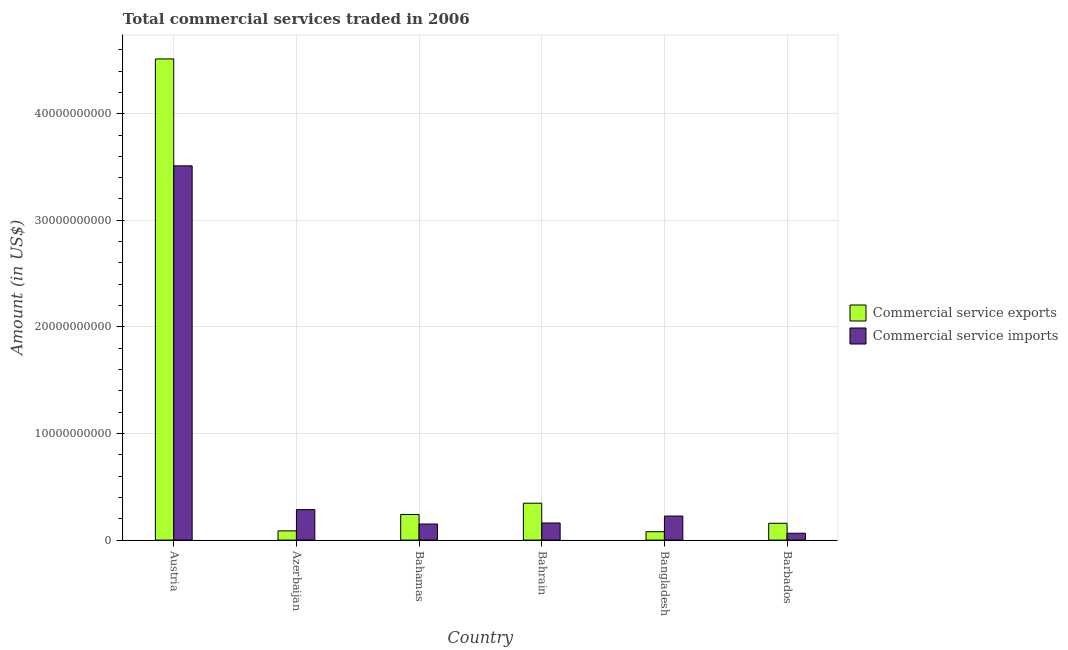What is the label of the 1st group of bars from the left?
Offer a terse response. Austria. In how many cases, is the number of bars for a given country not equal to the number of legend labels?
Offer a very short reply. 0. What is the amount of commercial service exports in Bahrain?
Keep it short and to the point. 3.46e+09. Across all countries, what is the maximum amount of commercial service imports?
Your answer should be very brief. 3.51e+1. Across all countries, what is the minimum amount of commercial service imports?
Offer a terse response. 6.43e+08. In which country was the amount of commercial service imports maximum?
Your response must be concise. Austria. In which country was the amount of commercial service exports minimum?
Ensure brevity in your answer.  Bangladesh. What is the total amount of commercial service imports in the graph?
Your answer should be compact. 4.40e+1. What is the difference between the amount of commercial service exports in Bahrain and that in Bangladesh?
Offer a very short reply. 2.68e+09. What is the difference between the amount of commercial service exports in Bangladesh and the amount of commercial service imports in Bahrain?
Provide a short and direct response. -8.19e+08. What is the average amount of commercial service imports per country?
Give a very brief answer. 7.33e+09. What is the difference between the amount of commercial service imports and amount of commercial service exports in Barbados?
Provide a short and direct response. -9.36e+08. In how many countries, is the amount of commercial service exports greater than 44000000000 US$?
Offer a terse response. 1. What is the ratio of the amount of commercial service imports in Austria to that in Bangladesh?
Offer a very short reply. 15.57. What is the difference between the highest and the second highest amount of commercial service exports?
Make the answer very short. 4.17e+1. What is the difference between the highest and the lowest amount of commercial service exports?
Your response must be concise. 4.44e+1. What does the 1st bar from the left in Bahrain represents?
Your response must be concise. Commercial service exports. What does the 2nd bar from the right in Barbados represents?
Provide a succinct answer. Commercial service exports. Are all the bars in the graph horizontal?
Offer a very short reply. No. What is the difference between two consecutive major ticks on the Y-axis?
Give a very brief answer. 1.00e+1. Are the values on the major ticks of Y-axis written in scientific E-notation?
Your response must be concise. No. Does the graph contain any zero values?
Your answer should be compact. No. Does the graph contain grids?
Your answer should be very brief. Yes. Where does the legend appear in the graph?
Your response must be concise. Center right. How many legend labels are there?
Your response must be concise. 2. What is the title of the graph?
Keep it short and to the point. Total commercial services traded in 2006. What is the label or title of the Y-axis?
Your answer should be very brief. Amount (in US$). What is the Amount (in US$) of Commercial service exports in Austria?
Your answer should be compact. 4.51e+1. What is the Amount (in US$) of Commercial service imports in Austria?
Ensure brevity in your answer.  3.51e+1. What is the Amount (in US$) in Commercial service exports in Azerbaijan?
Provide a succinct answer. 8.67e+08. What is the Amount (in US$) in Commercial service imports in Azerbaijan?
Ensure brevity in your answer.  2.86e+09. What is the Amount (in US$) in Commercial service exports in Bahamas?
Your answer should be very brief. 2.40e+09. What is the Amount (in US$) in Commercial service imports in Bahamas?
Your answer should be very brief. 1.51e+09. What is the Amount (in US$) of Commercial service exports in Bahrain?
Give a very brief answer. 3.46e+09. What is the Amount (in US$) of Commercial service imports in Bahrain?
Give a very brief answer. 1.61e+09. What is the Amount (in US$) in Commercial service exports in Bangladesh?
Ensure brevity in your answer.  7.87e+08. What is the Amount (in US$) of Commercial service imports in Bangladesh?
Make the answer very short. 2.26e+09. What is the Amount (in US$) of Commercial service exports in Barbados?
Give a very brief answer. 1.58e+09. What is the Amount (in US$) in Commercial service imports in Barbados?
Keep it short and to the point. 6.43e+08. Across all countries, what is the maximum Amount (in US$) in Commercial service exports?
Make the answer very short. 4.51e+1. Across all countries, what is the maximum Amount (in US$) of Commercial service imports?
Offer a terse response. 3.51e+1. Across all countries, what is the minimum Amount (in US$) in Commercial service exports?
Ensure brevity in your answer.  7.87e+08. Across all countries, what is the minimum Amount (in US$) in Commercial service imports?
Your response must be concise. 6.43e+08. What is the total Amount (in US$) of Commercial service exports in the graph?
Your answer should be compact. 5.42e+1. What is the total Amount (in US$) in Commercial service imports in the graph?
Give a very brief answer. 4.40e+1. What is the difference between the Amount (in US$) of Commercial service exports in Austria and that in Azerbaijan?
Your response must be concise. 4.43e+1. What is the difference between the Amount (in US$) in Commercial service imports in Austria and that in Azerbaijan?
Offer a very short reply. 3.22e+1. What is the difference between the Amount (in US$) of Commercial service exports in Austria and that in Bahamas?
Your answer should be very brief. 4.27e+1. What is the difference between the Amount (in US$) of Commercial service imports in Austria and that in Bahamas?
Offer a terse response. 3.36e+1. What is the difference between the Amount (in US$) of Commercial service exports in Austria and that in Bahrain?
Provide a succinct answer. 4.17e+1. What is the difference between the Amount (in US$) of Commercial service imports in Austria and that in Bahrain?
Your answer should be compact. 3.35e+1. What is the difference between the Amount (in US$) of Commercial service exports in Austria and that in Bangladesh?
Make the answer very short. 4.44e+1. What is the difference between the Amount (in US$) of Commercial service imports in Austria and that in Bangladesh?
Your answer should be very brief. 3.29e+1. What is the difference between the Amount (in US$) in Commercial service exports in Austria and that in Barbados?
Your response must be concise. 4.36e+1. What is the difference between the Amount (in US$) in Commercial service imports in Austria and that in Barbados?
Give a very brief answer. 3.45e+1. What is the difference between the Amount (in US$) of Commercial service exports in Azerbaijan and that in Bahamas?
Your answer should be compact. -1.54e+09. What is the difference between the Amount (in US$) in Commercial service imports in Azerbaijan and that in Bahamas?
Your answer should be very brief. 1.35e+09. What is the difference between the Amount (in US$) in Commercial service exports in Azerbaijan and that in Bahrain?
Make the answer very short. -2.60e+09. What is the difference between the Amount (in US$) in Commercial service imports in Azerbaijan and that in Bahrain?
Provide a short and direct response. 1.25e+09. What is the difference between the Amount (in US$) of Commercial service exports in Azerbaijan and that in Bangladesh?
Make the answer very short. 8.04e+07. What is the difference between the Amount (in US$) in Commercial service imports in Azerbaijan and that in Bangladesh?
Provide a succinct answer. 6.04e+08. What is the difference between the Amount (in US$) of Commercial service exports in Azerbaijan and that in Barbados?
Offer a very short reply. -7.12e+08. What is the difference between the Amount (in US$) of Commercial service imports in Azerbaijan and that in Barbados?
Keep it short and to the point. 2.22e+09. What is the difference between the Amount (in US$) in Commercial service exports in Bahamas and that in Bahrain?
Give a very brief answer. -1.06e+09. What is the difference between the Amount (in US$) in Commercial service imports in Bahamas and that in Bahrain?
Ensure brevity in your answer.  -9.57e+07. What is the difference between the Amount (in US$) of Commercial service exports in Bahamas and that in Bangladesh?
Your answer should be very brief. 1.62e+09. What is the difference between the Amount (in US$) in Commercial service imports in Bahamas and that in Bangladesh?
Provide a succinct answer. -7.46e+08. What is the difference between the Amount (in US$) of Commercial service exports in Bahamas and that in Barbados?
Give a very brief answer. 8.24e+08. What is the difference between the Amount (in US$) of Commercial service imports in Bahamas and that in Barbados?
Ensure brevity in your answer.  8.66e+08. What is the difference between the Amount (in US$) in Commercial service exports in Bahrain and that in Bangladesh?
Your answer should be very brief. 2.68e+09. What is the difference between the Amount (in US$) of Commercial service imports in Bahrain and that in Bangladesh?
Your answer should be compact. -6.50e+08. What is the difference between the Amount (in US$) of Commercial service exports in Bahrain and that in Barbados?
Ensure brevity in your answer.  1.88e+09. What is the difference between the Amount (in US$) in Commercial service imports in Bahrain and that in Barbados?
Your response must be concise. 9.62e+08. What is the difference between the Amount (in US$) in Commercial service exports in Bangladesh and that in Barbados?
Give a very brief answer. -7.92e+08. What is the difference between the Amount (in US$) of Commercial service imports in Bangladesh and that in Barbados?
Your answer should be very brief. 1.61e+09. What is the difference between the Amount (in US$) in Commercial service exports in Austria and the Amount (in US$) in Commercial service imports in Azerbaijan?
Give a very brief answer. 4.23e+1. What is the difference between the Amount (in US$) in Commercial service exports in Austria and the Amount (in US$) in Commercial service imports in Bahamas?
Ensure brevity in your answer.  4.36e+1. What is the difference between the Amount (in US$) in Commercial service exports in Austria and the Amount (in US$) in Commercial service imports in Bahrain?
Keep it short and to the point. 4.35e+1. What is the difference between the Amount (in US$) of Commercial service exports in Austria and the Amount (in US$) of Commercial service imports in Bangladesh?
Your answer should be compact. 4.29e+1. What is the difference between the Amount (in US$) of Commercial service exports in Austria and the Amount (in US$) of Commercial service imports in Barbados?
Your answer should be very brief. 4.45e+1. What is the difference between the Amount (in US$) of Commercial service exports in Azerbaijan and the Amount (in US$) of Commercial service imports in Bahamas?
Your answer should be compact. -6.43e+08. What is the difference between the Amount (in US$) in Commercial service exports in Azerbaijan and the Amount (in US$) in Commercial service imports in Bahrain?
Provide a short and direct response. -7.38e+08. What is the difference between the Amount (in US$) in Commercial service exports in Azerbaijan and the Amount (in US$) in Commercial service imports in Bangladesh?
Provide a succinct answer. -1.39e+09. What is the difference between the Amount (in US$) in Commercial service exports in Azerbaijan and the Amount (in US$) in Commercial service imports in Barbados?
Offer a terse response. 2.24e+08. What is the difference between the Amount (in US$) in Commercial service exports in Bahamas and the Amount (in US$) in Commercial service imports in Bahrain?
Your response must be concise. 7.98e+08. What is the difference between the Amount (in US$) of Commercial service exports in Bahamas and the Amount (in US$) of Commercial service imports in Bangladesh?
Ensure brevity in your answer.  1.48e+08. What is the difference between the Amount (in US$) in Commercial service exports in Bahamas and the Amount (in US$) in Commercial service imports in Barbados?
Give a very brief answer. 1.76e+09. What is the difference between the Amount (in US$) in Commercial service exports in Bahrain and the Amount (in US$) in Commercial service imports in Bangladesh?
Your answer should be compact. 1.21e+09. What is the difference between the Amount (in US$) of Commercial service exports in Bahrain and the Amount (in US$) of Commercial service imports in Barbados?
Provide a short and direct response. 2.82e+09. What is the difference between the Amount (in US$) of Commercial service exports in Bangladesh and the Amount (in US$) of Commercial service imports in Barbados?
Make the answer very short. 1.43e+08. What is the average Amount (in US$) in Commercial service exports per country?
Your answer should be compact. 9.04e+09. What is the average Amount (in US$) of Commercial service imports per country?
Offer a very short reply. 7.33e+09. What is the difference between the Amount (in US$) in Commercial service exports and Amount (in US$) in Commercial service imports in Austria?
Your answer should be very brief. 1.00e+1. What is the difference between the Amount (in US$) in Commercial service exports and Amount (in US$) in Commercial service imports in Azerbaijan?
Offer a very short reply. -1.99e+09. What is the difference between the Amount (in US$) in Commercial service exports and Amount (in US$) in Commercial service imports in Bahamas?
Keep it short and to the point. 8.94e+08. What is the difference between the Amount (in US$) of Commercial service exports and Amount (in US$) of Commercial service imports in Bahrain?
Keep it short and to the point. 1.86e+09. What is the difference between the Amount (in US$) in Commercial service exports and Amount (in US$) in Commercial service imports in Bangladesh?
Offer a very short reply. -1.47e+09. What is the difference between the Amount (in US$) in Commercial service exports and Amount (in US$) in Commercial service imports in Barbados?
Your response must be concise. 9.36e+08. What is the ratio of the Amount (in US$) of Commercial service exports in Austria to that in Azerbaijan?
Provide a succinct answer. 52.07. What is the ratio of the Amount (in US$) of Commercial service imports in Austria to that in Azerbaijan?
Your answer should be very brief. 12.28. What is the ratio of the Amount (in US$) of Commercial service exports in Austria to that in Bahamas?
Ensure brevity in your answer.  18.78. What is the ratio of the Amount (in US$) of Commercial service imports in Austria to that in Bahamas?
Provide a succinct answer. 23.26. What is the ratio of the Amount (in US$) of Commercial service exports in Austria to that in Bahrain?
Provide a short and direct response. 13.04. What is the ratio of the Amount (in US$) of Commercial service imports in Austria to that in Bahrain?
Make the answer very short. 21.87. What is the ratio of the Amount (in US$) of Commercial service exports in Austria to that in Bangladesh?
Keep it short and to the point. 57.39. What is the ratio of the Amount (in US$) of Commercial service imports in Austria to that in Bangladesh?
Give a very brief answer. 15.57. What is the ratio of the Amount (in US$) of Commercial service exports in Austria to that in Barbados?
Offer a very short reply. 28.59. What is the ratio of the Amount (in US$) of Commercial service imports in Austria to that in Barbados?
Keep it short and to the point. 54.59. What is the ratio of the Amount (in US$) in Commercial service exports in Azerbaijan to that in Bahamas?
Ensure brevity in your answer.  0.36. What is the ratio of the Amount (in US$) in Commercial service imports in Azerbaijan to that in Bahamas?
Offer a terse response. 1.89. What is the ratio of the Amount (in US$) in Commercial service exports in Azerbaijan to that in Bahrain?
Offer a very short reply. 0.25. What is the ratio of the Amount (in US$) in Commercial service imports in Azerbaijan to that in Bahrain?
Provide a short and direct response. 1.78. What is the ratio of the Amount (in US$) in Commercial service exports in Azerbaijan to that in Bangladesh?
Ensure brevity in your answer.  1.1. What is the ratio of the Amount (in US$) of Commercial service imports in Azerbaijan to that in Bangladesh?
Give a very brief answer. 1.27. What is the ratio of the Amount (in US$) in Commercial service exports in Azerbaijan to that in Barbados?
Your answer should be very brief. 0.55. What is the ratio of the Amount (in US$) of Commercial service imports in Azerbaijan to that in Barbados?
Make the answer very short. 4.45. What is the ratio of the Amount (in US$) of Commercial service exports in Bahamas to that in Bahrain?
Provide a succinct answer. 0.69. What is the ratio of the Amount (in US$) in Commercial service imports in Bahamas to that in Bahrain?
Offer a terse response. 0.94. What is the ratio of the Amount (in US$) of Commercial service exports in Bahamas to that in Bangladesh?
Ensure brevity in your answer.  3.06. What is the ratio of the Amount (in US$) in Commercial service imports in Bahamas to that in Bangladesh?
Ensure brevity in your answer.  0.67. What is the ratio of the Amount (in US$) in Commercial service exports in Bahamas to that in Barbados?
Provide a succinct answer. 1.52. What is the ratio of the Amount (in US$) in Commercial service imports in Bahamas to that in Barbados?
Your answer should be very brief. 2.35. What is the ratio of the Amount (in US$) of Commercial service exports in Bahrain to that in Bangladesh?
Your answer should be compact. 4.4. What is the ratio of the Amount (in US$) in Commercial service imports in Bahrain to that in Bangladesh?
Your answer should be compact. 0.71. What is the ratio of the Amount (in US$) in Commercial service exports in Bahrain to that in Barbados?
Provide a short and direct response. 2.19. What is the ratio of the Amount (in US$) of Commercial service imports in Bahrain to that in Barbados?
Provide a succinct answer. 2.5. What is the ratio of the Amount (in US$) in Commercial service exports in Bangladesh to that in Barbados?
Provide a succinct answer. 0.5. What is the ratio of the Amount (in US$) in Commercial service imports in Bangladesh to that in Barbados?
Keep it short and to the point. 3.51. What is the difference between the highest and the second highest Amount (in US$) in Commercial service exports?
Keep it short and to the point. 4.17e+1. What is the difference between the highest and the second highest Amount (in US$) of Commercial service imports?
Offer a terse response. 3.22e+1. What is the difference between the highest and the lowest Amount (in US$) of Commercial service exports?
Give a very brief answer. 4.44e+1. What is the difference between the highest and the lowest Amount (in US$) of Commercial service imports?
Your response must be concise. 3.45e+1. 